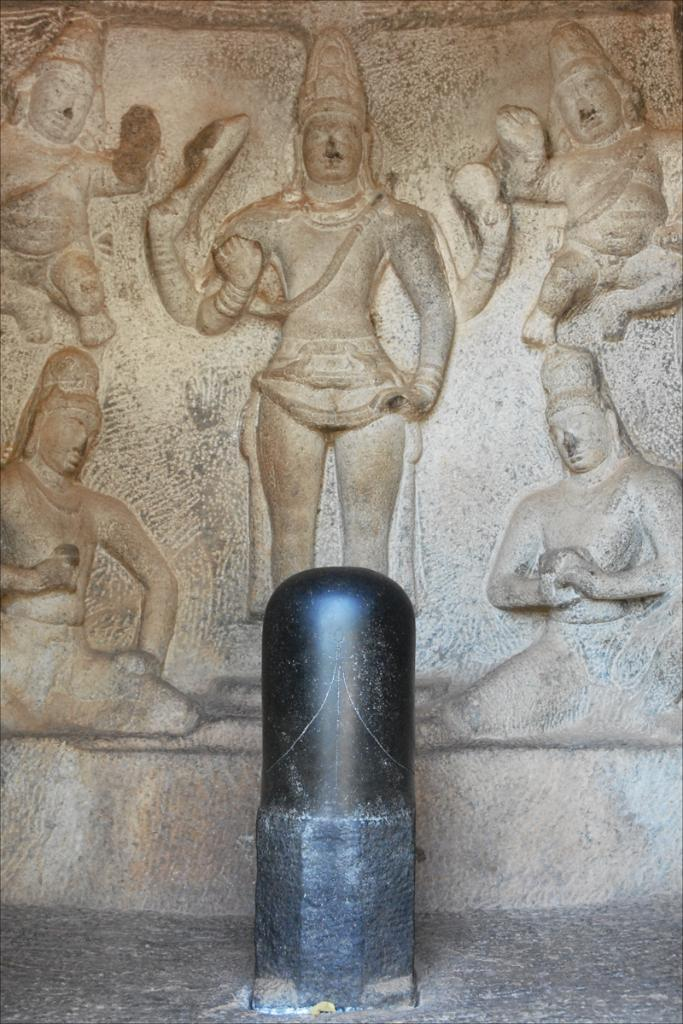What is the main subject in the image? There is a statue in the image. Can you describe the statue? Unfortunately, the provided facts do not give any details about the statue's appearance or characteristics. What else can be seen in the background of the image? There are sculptures on the wall in the background of the image. What type of beds are visible in the image? There are no beds present in the image. What belief is depicted in the image? The provided facts do not give any information about beliefs or themes depicted in the image. 